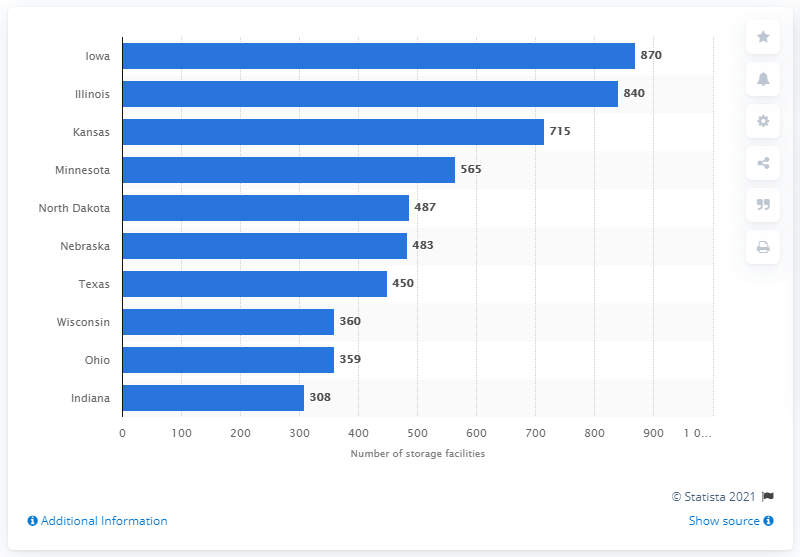Highlight a few significant elements in this photo. In December 2018, Iowa had a total of 870 off-farm storage facilities. 